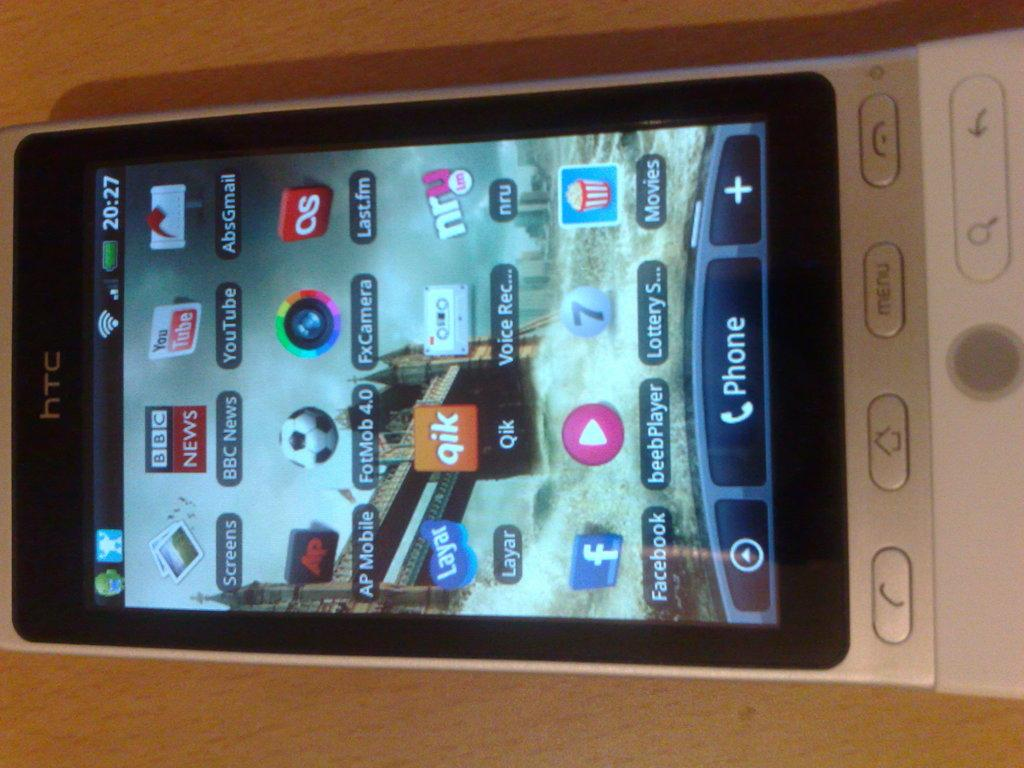<image>
Provide a brief description of the given image. A HTC phone  has several apps added to its home screen. 